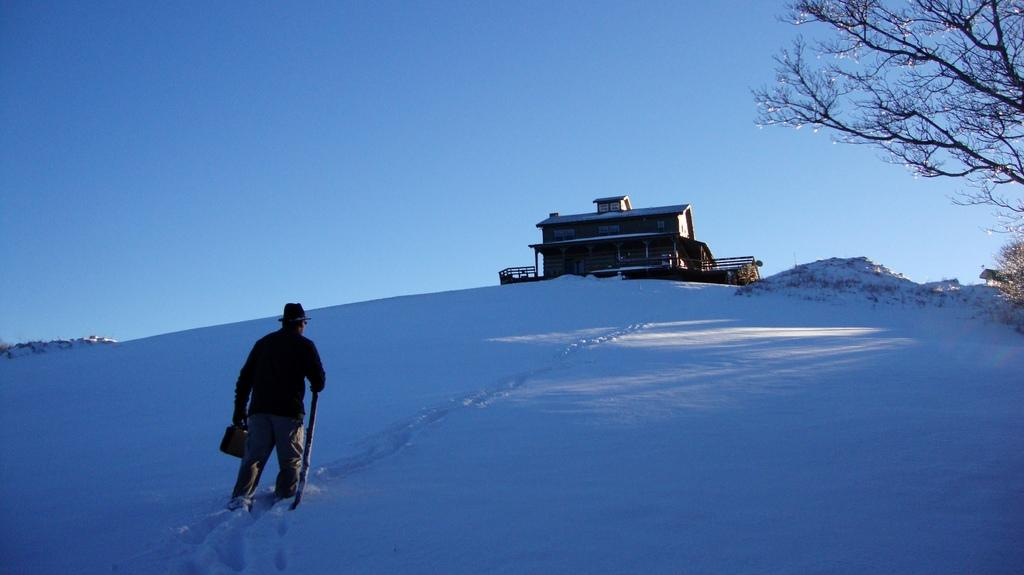What is the person in the image doing? The person is walking on snow in the image. What is the person holding while walking on snow? The person is holding an object and a stick. What can be seen in the background of the image? There is a building, trees, and the sky visible in the background of the image. How many jellyfish can be seen swimming in the snow in the image? There are no jellyfish present in the image, as it depicts a person walking on snow. 